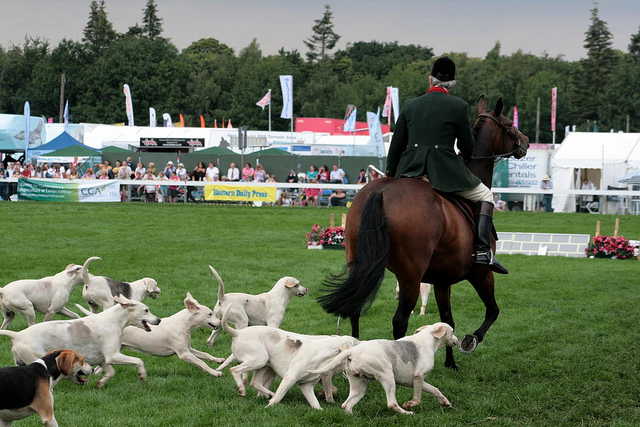Identify the text contained in this image. Dally CCA 